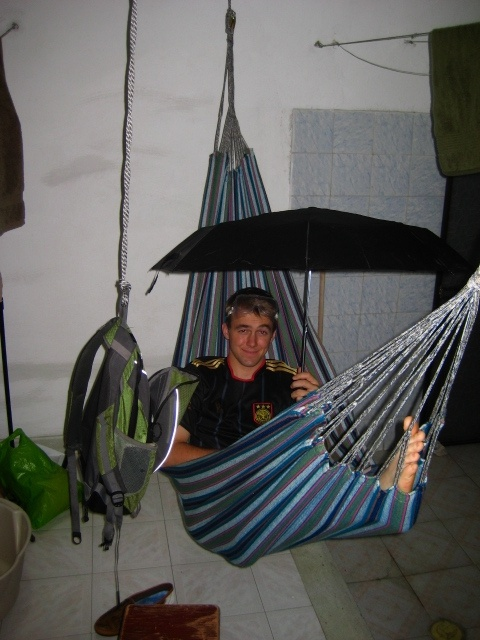Describe the objects in this image and their specific colors. I can see backpack in gray, black, and darkgreen tones, umbrella in gray, black, and darkgray tones, and people in gray, black, maroon, and brown tones in this image. 